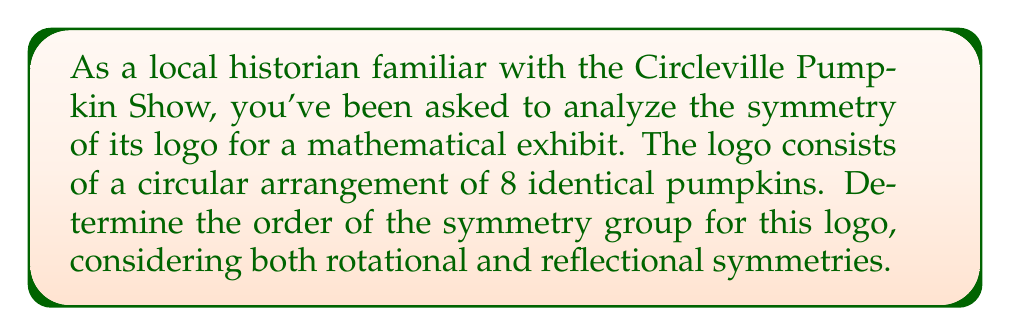Help me with this question. To determine the order of the symmetry group for the Circleville Pumpkin Show logo, we need to consider both rotational and reflectional symmetries:

1. Rotational symmetry:
   The logo has 8 identical pumpkins arranged in a circle. This means it has 8-fold rotational symmetry.
   Rotations: $$360^\circ/8 = 45^\circ$$ per rotation
   Number of distinct rotations: 8 (including the identity rotation)

2. Reflectional symmetry:
   With 8 pumpkins, there are 8 lines of reflection:
   - 4 lines passing through opposite pumpkins
   - 4 lines passing between adjacent pumpkins

3. Symmetry group:
   The symmetry group of this logo is the dihedral group $D_8$.

4. Order of the symmetry group:
   The order of $D_8$ is given by the formula:
   $$|D_n| = 2n$$
   Where $n$ is the number of rotational symmetries.
   
   In this case: $$|D_8| = 2 \cdot 8 = 16$$

The 16 symmetries consist of:
- 8 rotations (including identity)
- 8 reflections

This group is isomorphic to the symmetries of a regular octagon, which matches the arrangement of the 8 pumpkins in the logo.
Answer: The order of the symmetry group for the Circleville Pumpkin Show logo is 16. 